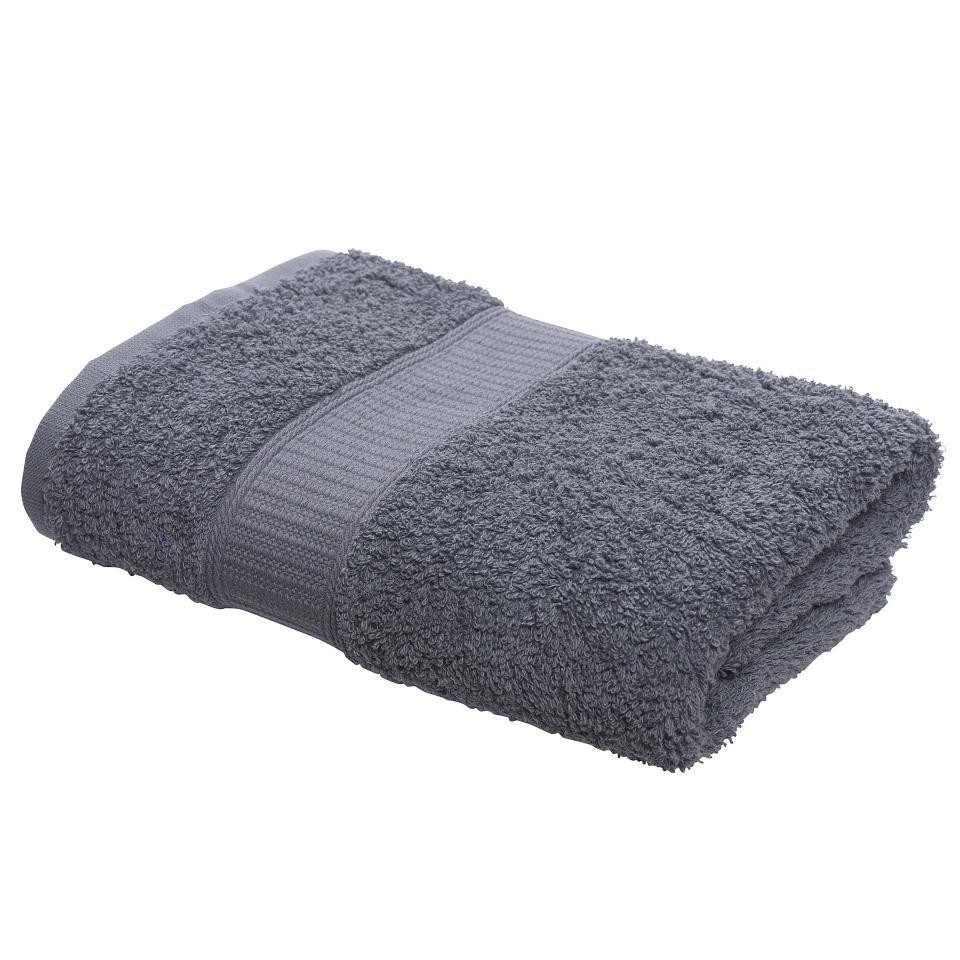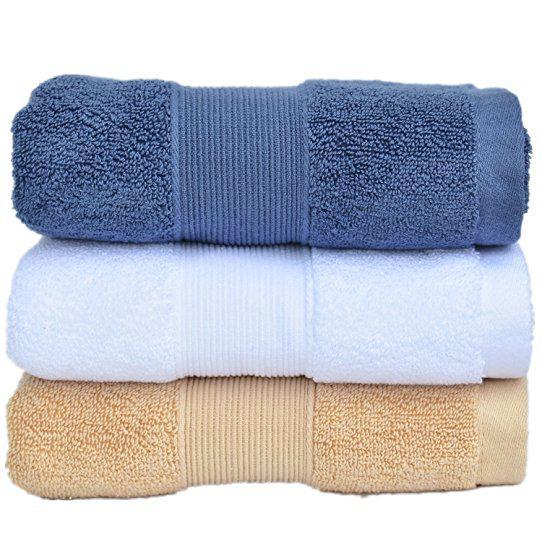The first image is the image on the left, the second image is the image on the right. Considering the images on both sides, is "In at least one image there is a tower of three folded towels." valid? Answer yes or no. Yes. The first image is the image on the left, the second image is the image on the right. For the images displayed, is the sentence "The left image shows exactly three towels, in navy, white and brown, with gold bands of """"Greek key"""" patterns on the towel's edge." factually correct? Answer yes or no. No. 